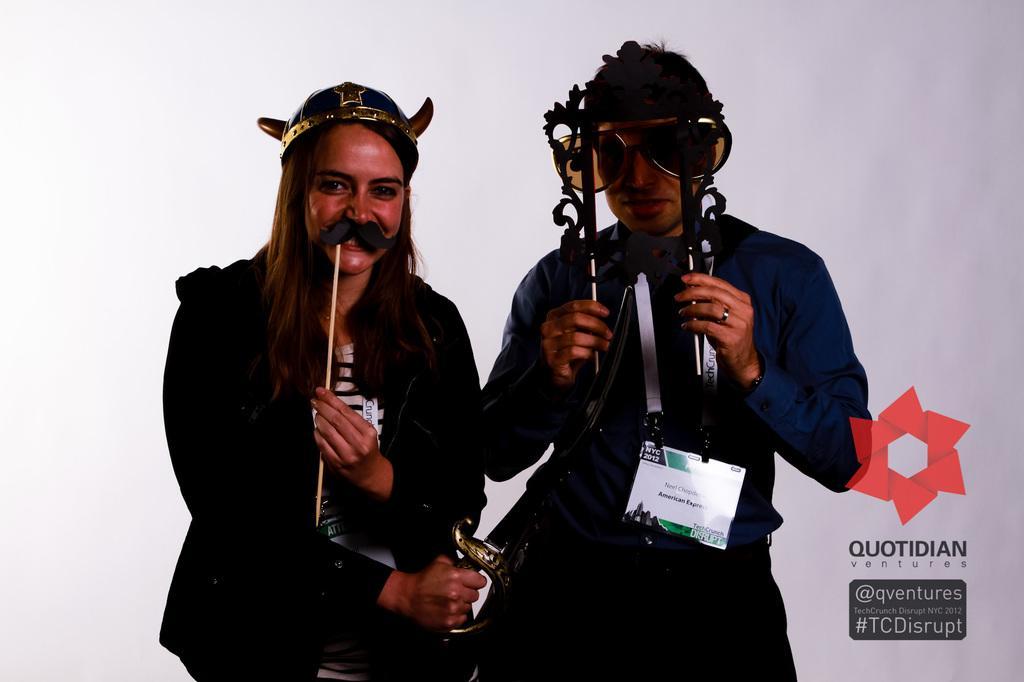In one or two sentences, can you explain what this image depicts? In this picture we can see two people, they are holding sticks, one person is wearing an id card, goggles, another person is wearing a head wear, holding a sword, here we can see a logo, symbols and some text and in the background we can see it is white color. 